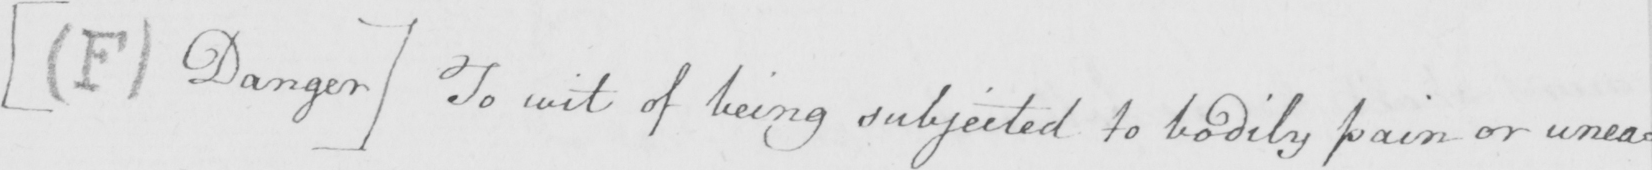What is written in this line of handwriting? [  ( F )  Danger ]  to wit of being subjected to bodily pain or unea : 